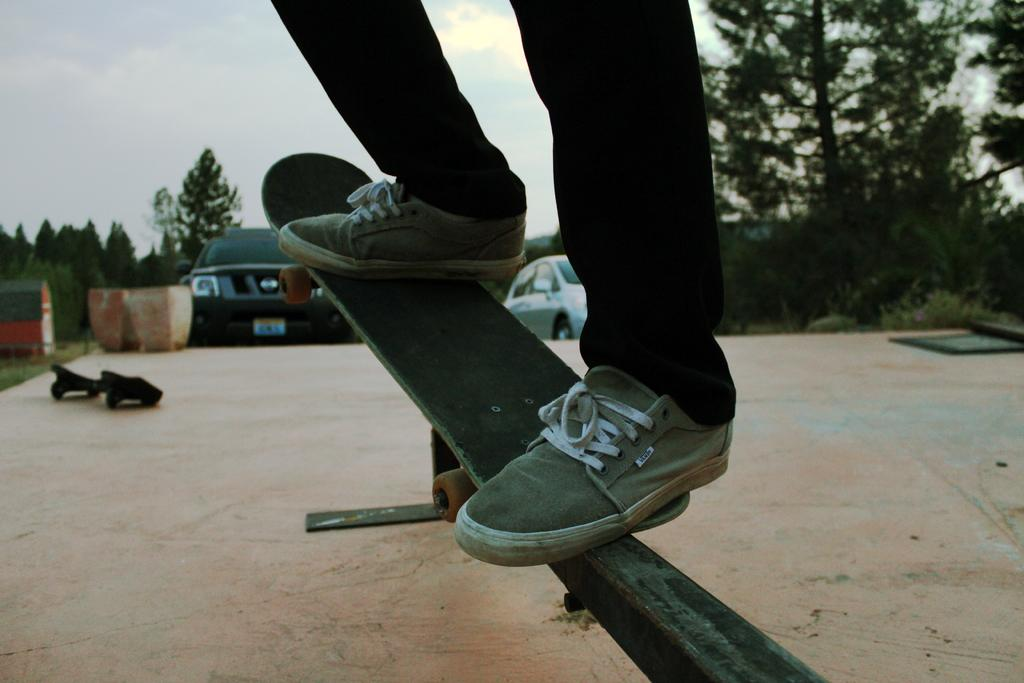What is the person in the image doing? The person is standing on a skateboard. What is the skateboard resting on? The skateboard is on a metal object. What can be seen in the background of the image? There are trees and cars in the background of the image. What is visible at the top of the image? The sky is visible at the top of the image. What type of loaf is being used to patch the button in the image? There is no loaf, patch, or button present in the image. 